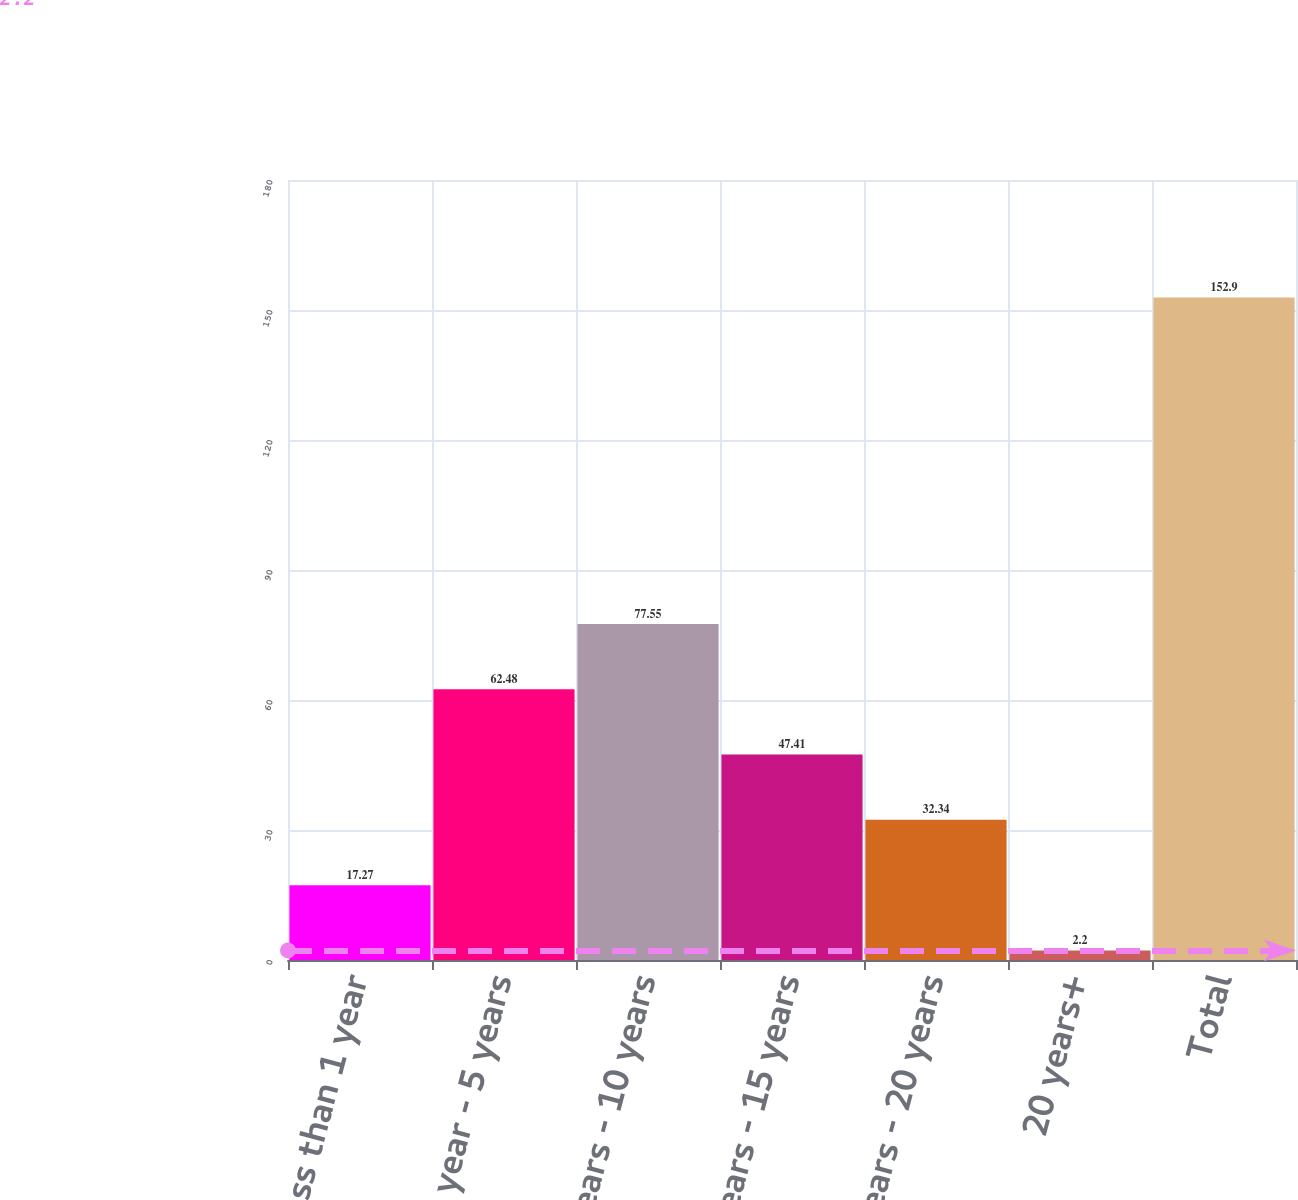<chart> <loc_0><loc_0><loc_500><loc_500><bar_chart><fcel>less than 1 year<fcel>1 year - 5 years<fcel>5 years - 10 years<fcel>10 years - 15 years<fcel>15 years - 20 years<fcel>20 years+<fcel>Total<nl><fcel>17.27<fcel>62.48<fcel>77.55<fcel>47.41<fcel>32.34<fcel>2.2<fcel>152.9<nl></chart> 